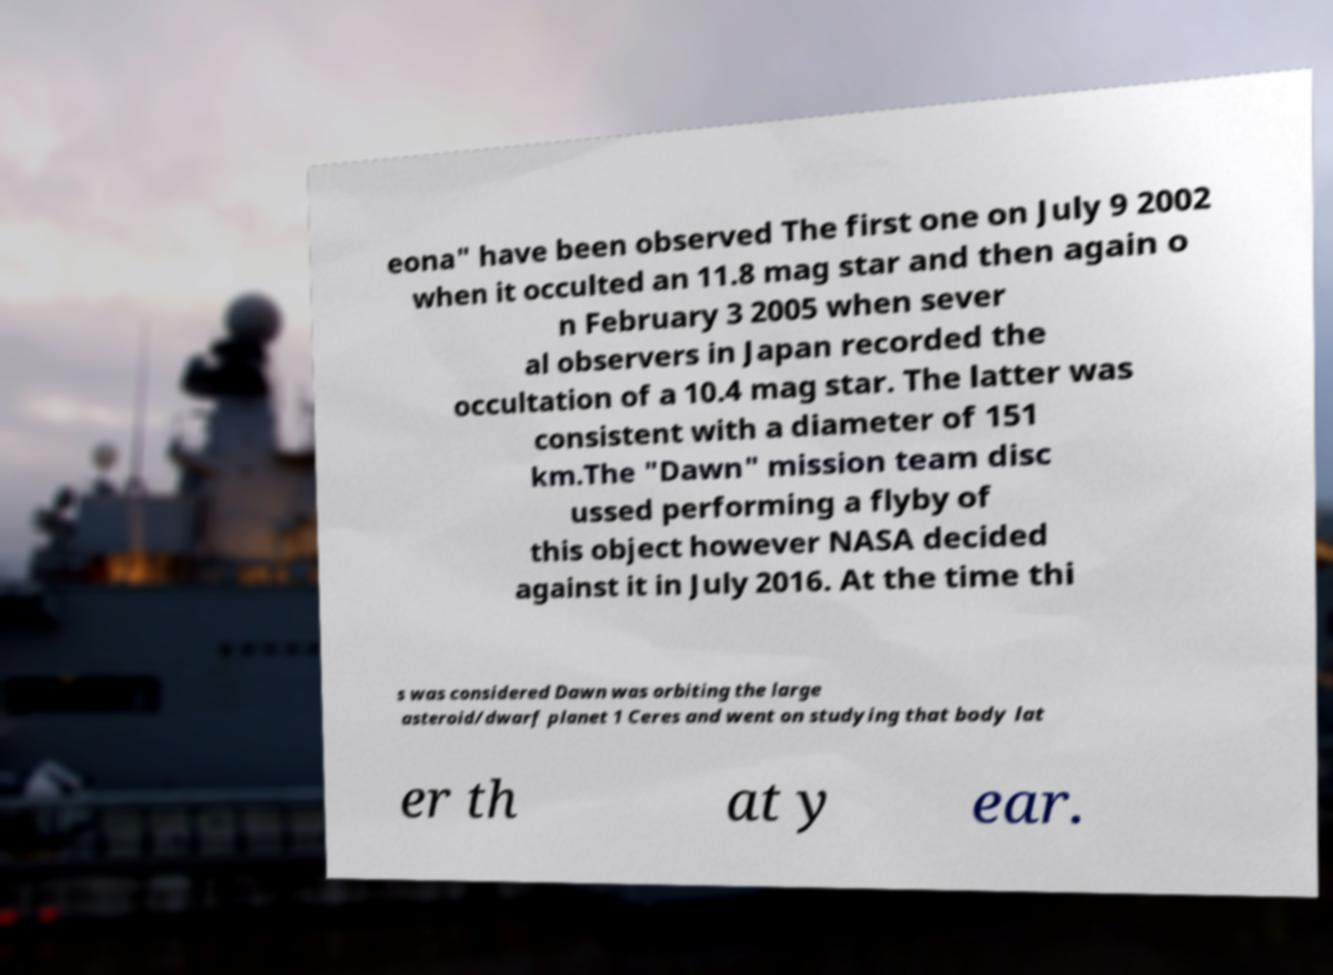Can you accurately transcribe the text from the provided image for me? eona" have been observed The first one on July 9 2002 when it occulted an 11.8 mag star and then again o n February 3 2005 when sever al observers in Japan recorded the occultation of a 10.4 mag star. The latter was consistent with a diameter of 151 km.The "Dawn" mission team disc ussed performing a flyby of this object however NASA decided against it in July 2016. At the time thi s was considered Dawn was orbiting the large asteroid/dwarf planet 1 Ceres and went on studying that body lat er th at y ear. 